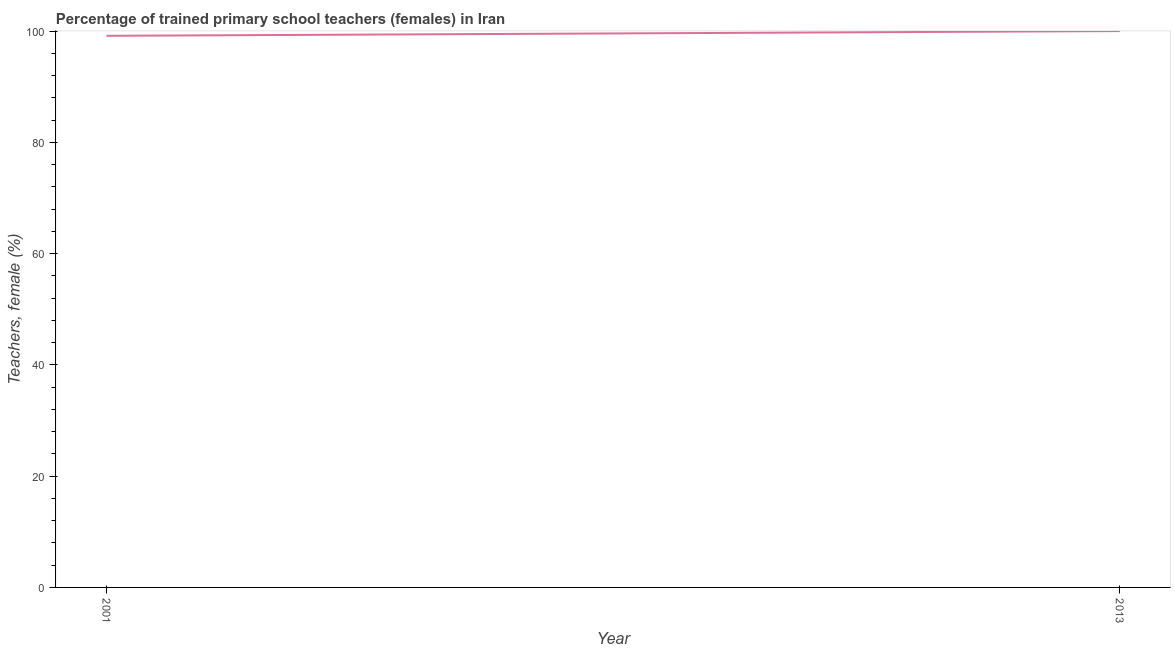What is the percentage of trained female teachers in 2013?
Your response must be concise. 100. Across all years, what is the minimum percentage of trained female teachers?
Provide a short and direct response. 99.14. In which year was the percentage of trained female teachers maximum?
Your answer should be very brief. 2013. In which year was the percentage of trained female teachers minimum?
Provide a succinct answer. 2001. What is the sum of the percentage of trained female teachers?
Your answer should be very brief. 199.14. What is the difference between the percentage of trained female teachers in 2001 and 2013?
Offer a very short reply. -0.86. What is the average percentage of trained female teachers per year?
Offer a terse response. 99.57. What is the median percentage of trained female teachers?
Provide a short and direct response. 99.57. In how many years, is the percentage of trained female teachers greater than 68 %?
Your answer should be compact. 2. What is the ratio of the percentage of trained female teachers in 2001 to that in 2013?
Your response must be concise. 0.99. Is the percentage of trained female teachers in 2001 less than that in 2013?
Your answer should be compact. Yes. Does the percentage of trained female teachers monotonically increase over the years?
Keep it short and to the point. Yes. Does the graph contain grids?
Provide a succinct answer. No. What is the title of the graph?
Give a very brief answer. Percentage of trained primary school teachers (females) in Iran. What is the label or title of the X-axis?
Keep it short and to the point. Year. What is the label or title of the Y-axis?
Give a very brief answer. Teachers, female (%). What is the Teachers, female (%) in 2001?
Provide a short and direct response. 99.14. What is the Teachers, female (%) of 2013?
Keep it short and to the point. 100. What is the difference between the Teachers, female (%) in 2001 and 2013?
Your response must be concise. -0.86. 